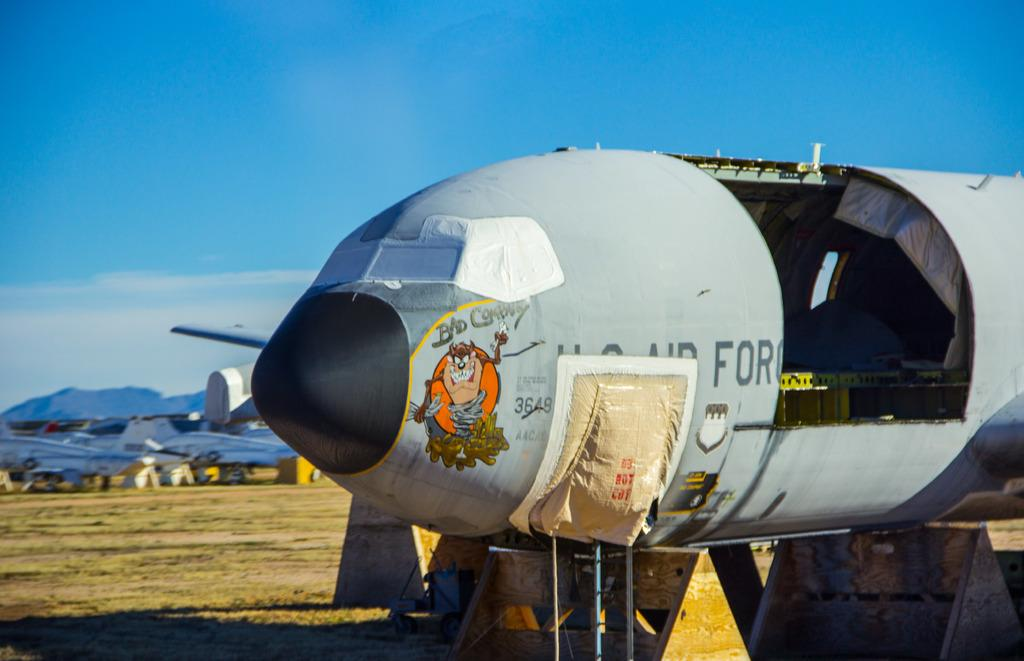<image>
Relay a brief, clear account of the picture shown. A plane with a hatch open with the word For to the side of it 